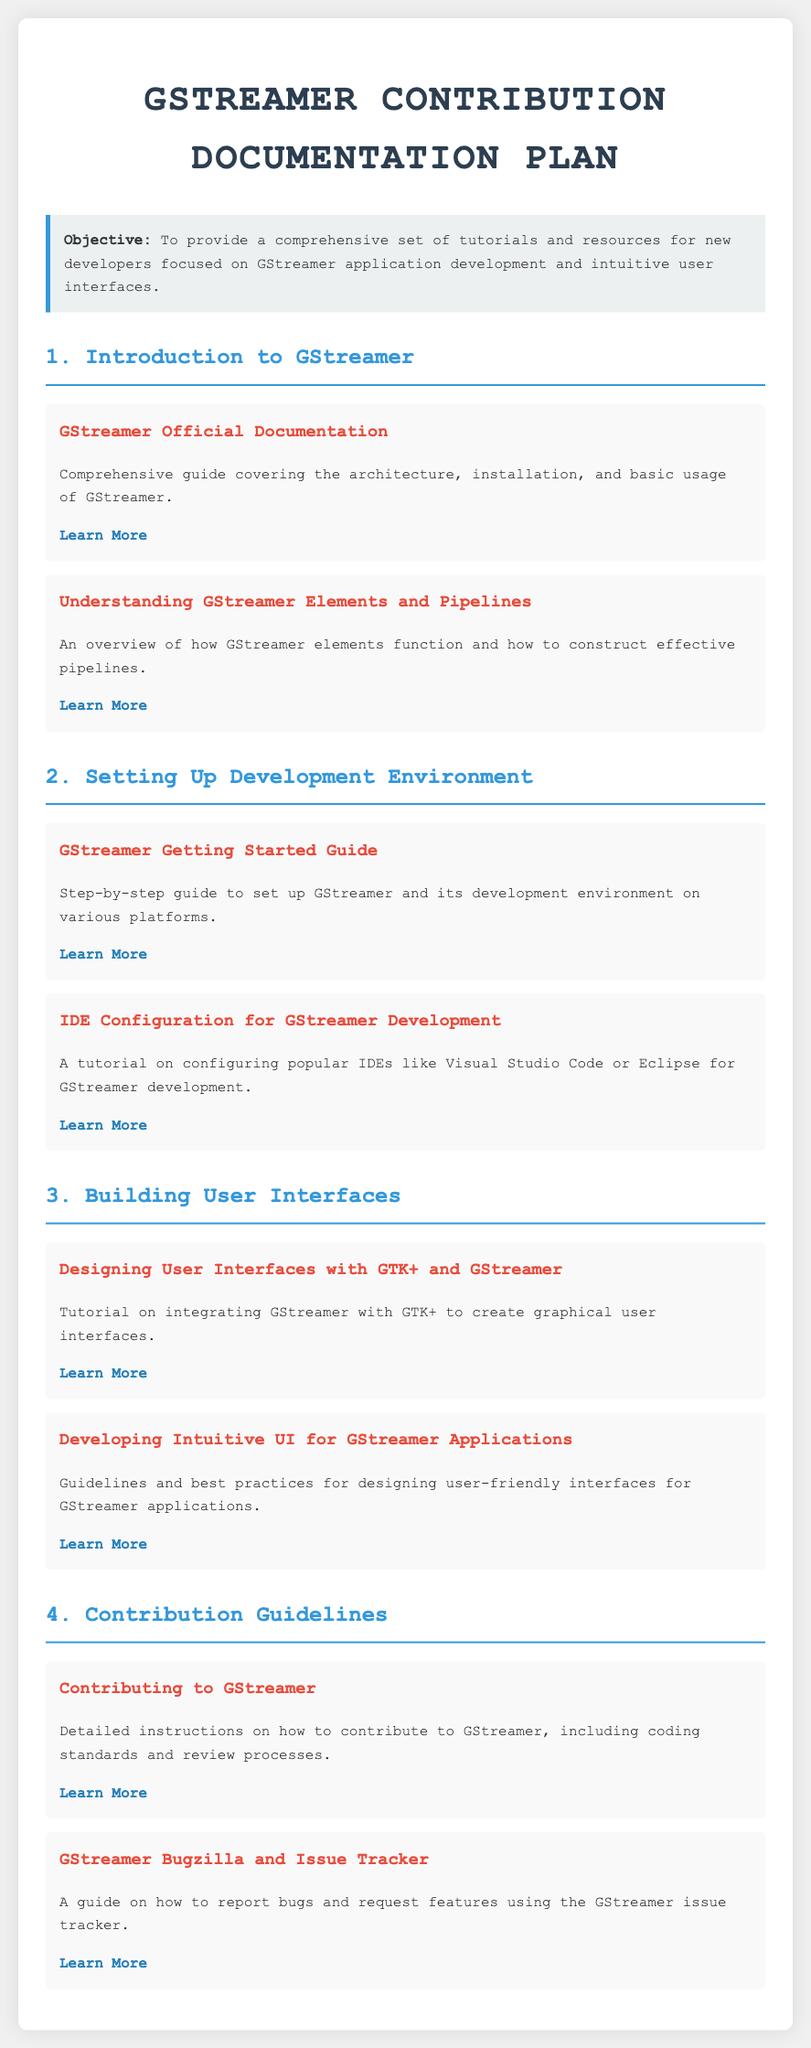What is the objective of the documentation plan? The objective is highlighted in a specific section of the document, describing the goal of providing resources for new developers.
Answer: To provide a comprehensive set of tutorials and resources for new developers focused on GStreamer application development and intuitive user interfaces What is the first tutorial listed under 'Introduction to GStreamer'? The first tutorial listed addresses the official documentation of GStreamer, which covers fundamental aspects.
Answer: GStreamer Official Documentation How many sections are there in the documentation plan? The document outlines four main sections, each focusing on different aspects of GStreamer contribution.
Answer: 4 Which tutorial focuses on designing user-friendly interfaces? This tutorial is specifically dedicated to discussing best practices for UI design within GStreamer applications.
Answer: Developing Intuitive UI for GStreamer Applications What platform configurations are discussed in the 'Setting Up Development Environment' section? The discussion includes the step-by-step guide for different platforms for setting up the development environment.
Answer: Various platforms What is the link for learning about contributing to GStreamer? The document contains an actionable link leading to detailed instructions on contributions.
Answer: https://gstreamer.freedesktop.org/documentation/contributing/index.html Which library is mentioned for creating graphical user interfaces in the documentation? The document mentions a specific library that integrates well with GStreamer for UI development.
Answer: GTK+ What type of resource is provided about bug reporting? The document specifies a guide that instructs users on how to report bugs effectively.
Answer: A guide on how to report bugs and request features 